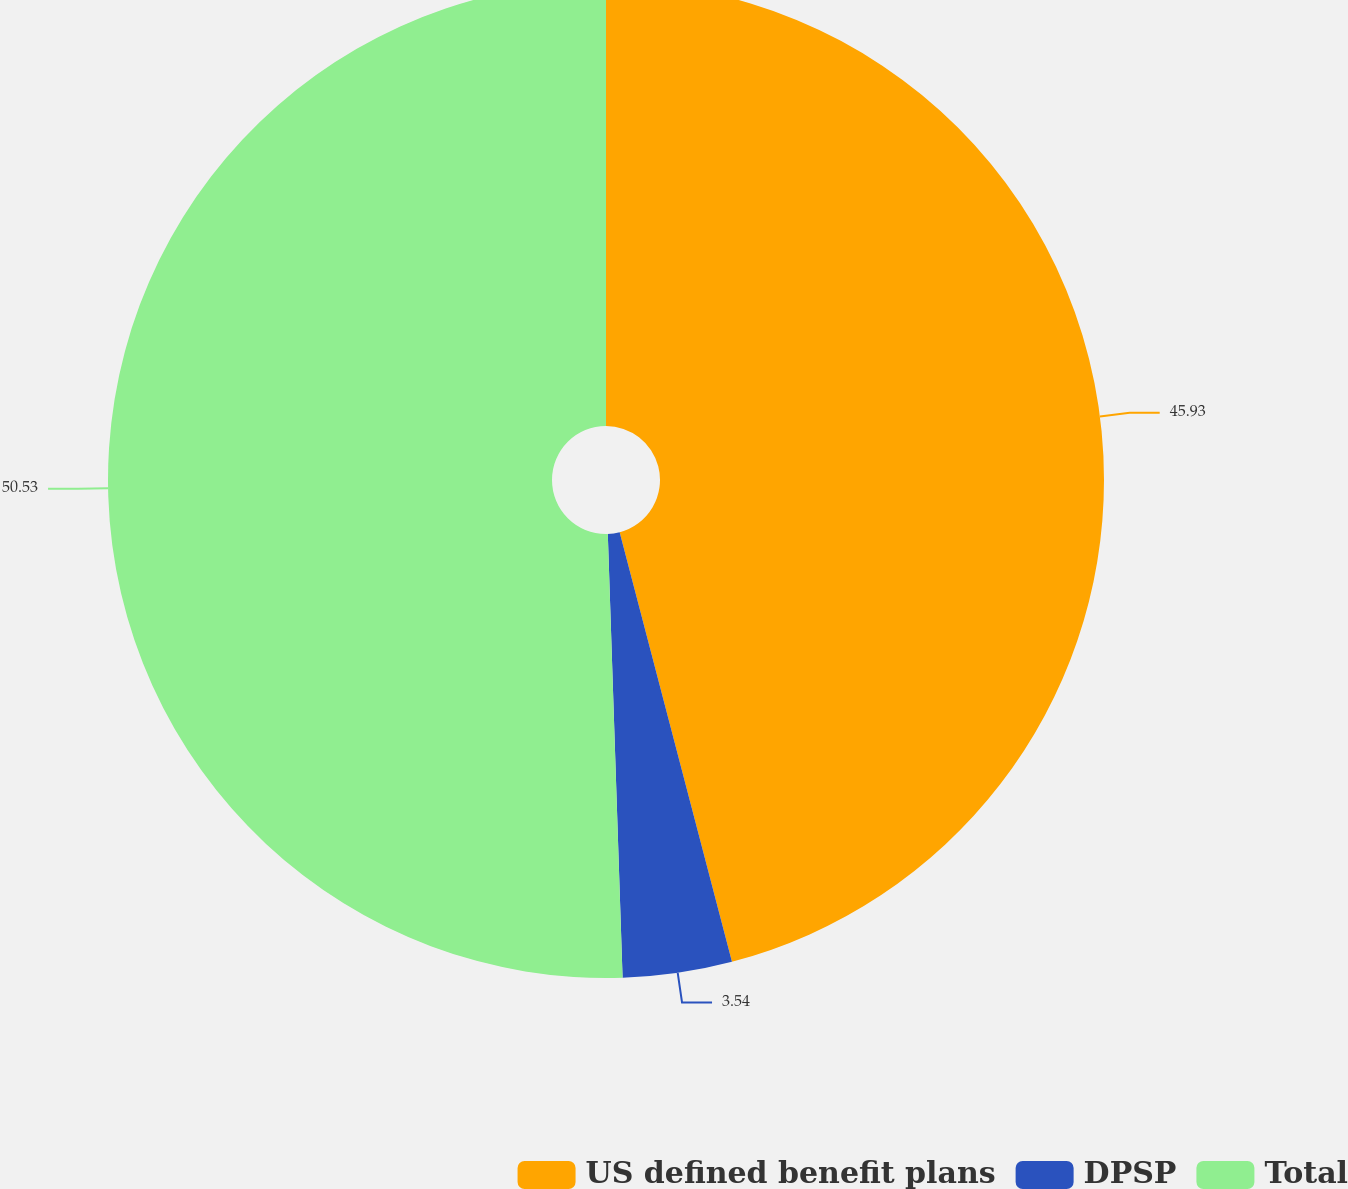Convert chart. <chart><loc_0><loc_0><loc_500><loc_500><pie_chart><fcel>US defined benefit plans<fcel>DPSP<fcel>Total<nl><fcel>45.93%<fcel>3.54%<fcel>50.53%<nl></chart> 